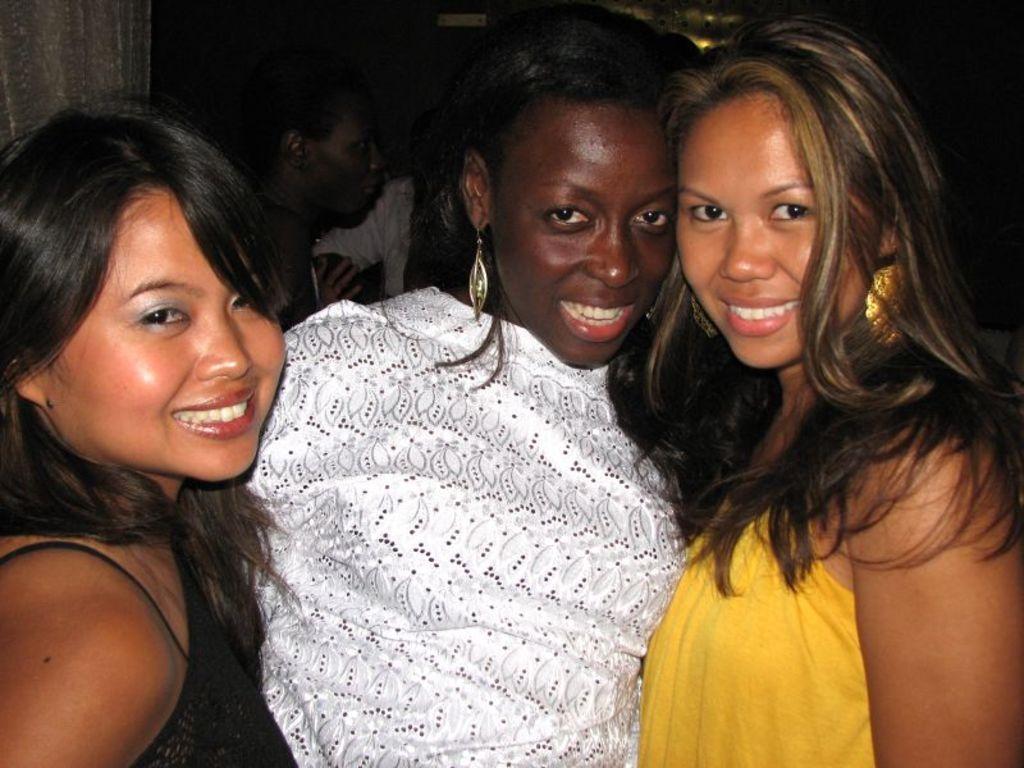Please provide a concise description of this image. In the center of the image we can see three persons are standing and they are smiling and they are in different costumes. In the background, we can see a few people and a few other objects. 